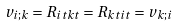Convert formula to latex. <formula><loc_0><loc_0><loc_500><loc_500>v _ { i ; k } = R _ { i t k t } = R _ { k t i t } = v _ { k ; i }</formula> 